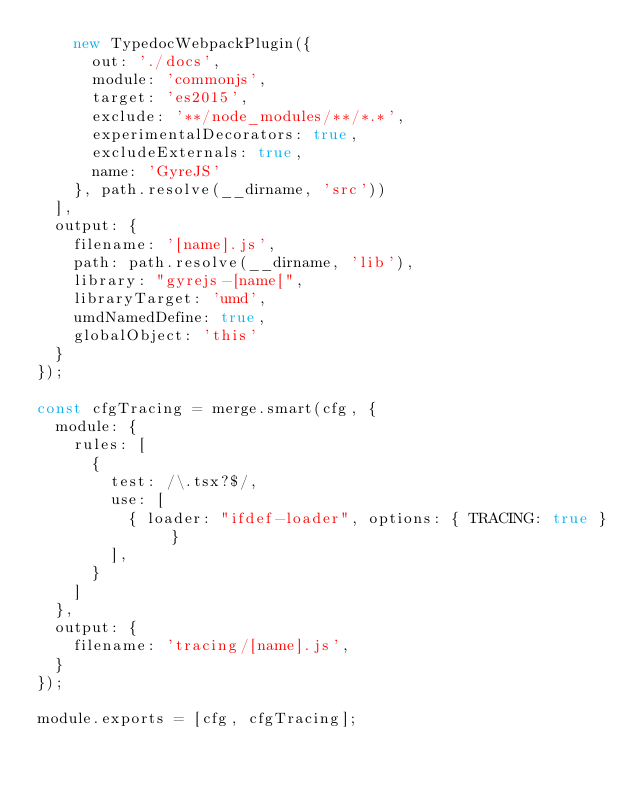Convert code to text. <code><loc_0><loc_0><loc_500><loc_500><_JavaScript_>    new TypedocWebpackPlugin({
      out: './docs',
      module: 'commonjs',
      target: 'es2015',
      exclude: '**/node_modules/**/*.*',
      experimentalDecorators: true,
      excludeExternals: true,
      name: 'GyreJS'
    }, path.resolve(__dirname, 'src'))
  ],
  output: {
    filename: '[name].js',
    path: path.resolve(__dirname, 'lib'),
    library: "gyrejs-[name[",
    libraryTarget: 'umd',
    umdNamedDefine: true,
    globalObject: 'this'
  }
});

const cfgTracing = merge.smart(cfg, {
  module: {
    rules: [
      {
        test: /\.tsx?$/,
        use: [
          { loader: "ifdef-loader", options: { TRACING: true } }
        ],
      }
    ]
  },
  output: {
    filename: 'tracing/[name].js',
  }
});

module.exports = [cfg, cfgTracing];
</code> 